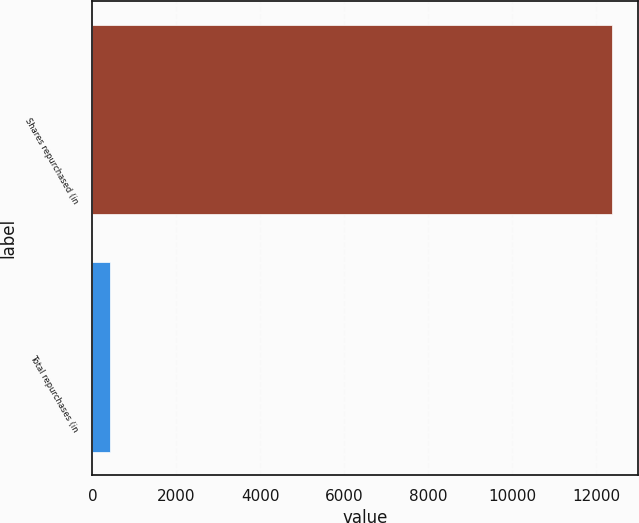Convert chart to OTSL. <chart><loc_0><loc_0><loc_500><loc_500><bar_chart><fcel>Shares repurchased (in<fcel>Total repurchases (in<nl><fcel>12390<fcel>410<nl></chart> 